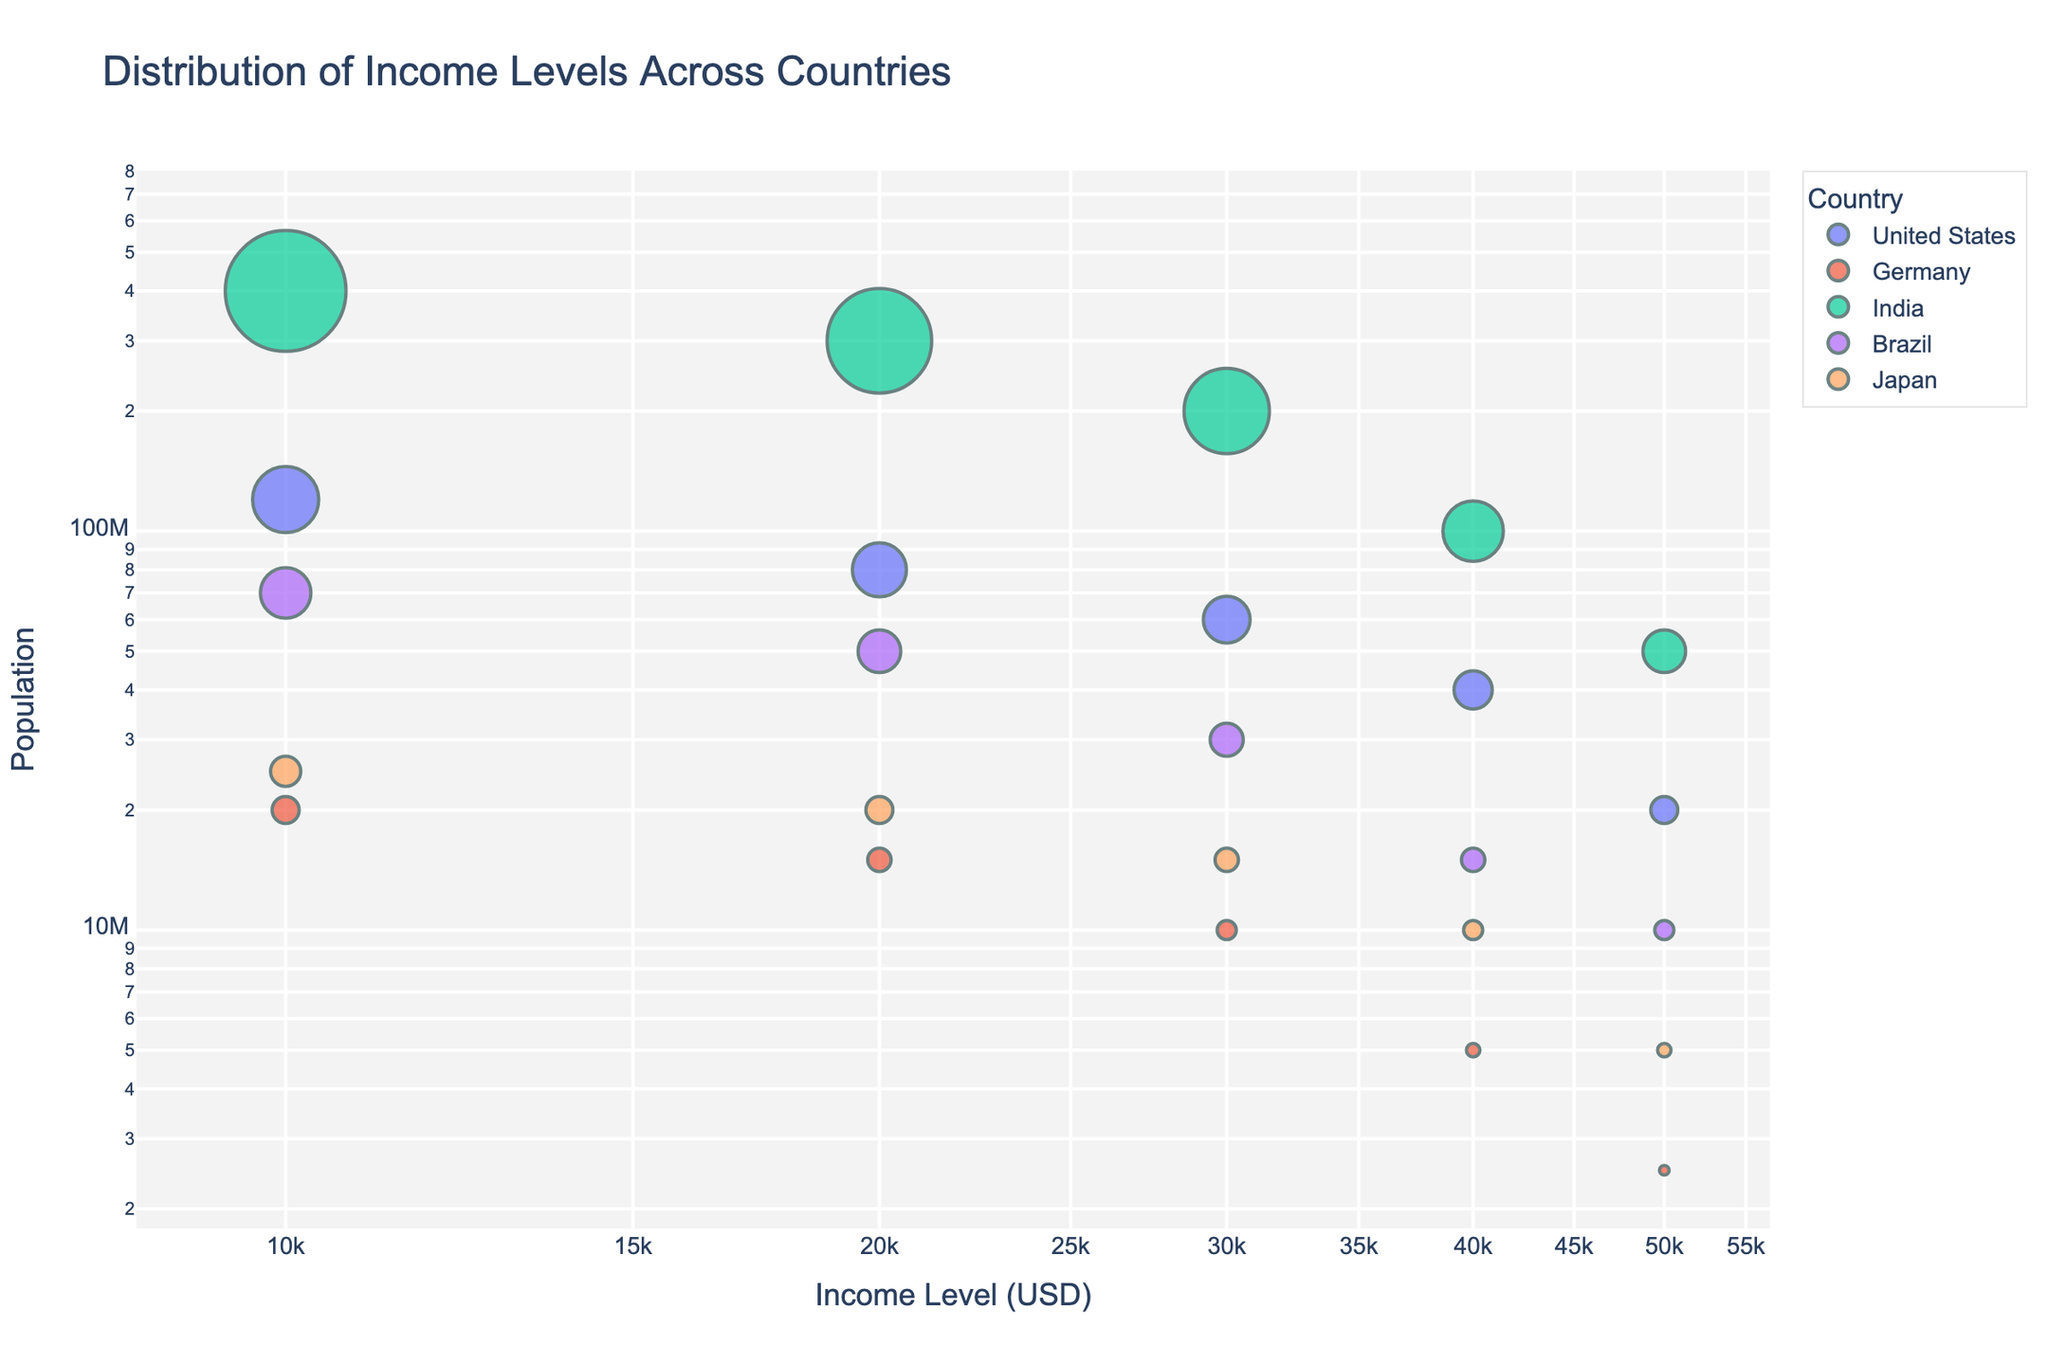What is the title of the plot? The title is usually displayed prominently at the top of the plot. It provides a summary of what the plot represents.
Answer: Distribution of Income Levels Across Countries Which country has the highest population at the $10,000 income level? To determine this, look at the data points representing each country's population at the $10,000 income level. The country with the highest y-axis value at this x-axis point has the highest population.
Answer: India What is the population of Japan at the $50,000 income level? Find the data point representing Japan for the $50,000 income level on the x-axis and check the corresponding y-axis value.
Answer: 5,000,000 How does the population of Brazil at $20,000 income level compare with that of Germany at the same income level? Locate the data points for Brazil and Germany at the $20,000 income level on the x-axis. Compare the corresponding y-axis values to see which one is higher.
Answer: Brazil has a higher population than Germany Which country has the smallest population at the $30,000 income level, excluding Brazil? Identify the data points for each country at the $30,000 income level on the x-axis. Compare the y-axis values and find the smallest one, excluding Brazil.
Answer: Germany What is the total population of all countries at $40,000 income level? Sum the population values for all countries at the $40,000 income level. For the United States it's 40,000,000, Germany it's 5,000,000, India it's 100,000,000, Brazil it's 15,000,000, and Japan it's 10,000,000. The total is 40,000,000 + 5,000,000 + 100,000,000 + 15,000,000 + 10,000,000.
Answer: 170,000,000 Among the given income levels, which one shows the most even distribution of populations across all countries? Check the data points for each income level and look at the spread of y-axis values for different countries. The income level where the y-axis values are more similar indicates a more even distribution.
Answer: $50,000 For the United States, how does the population at $30,000 income level compare to that at $40,000? Compare the y-axis values for the United States at the $30,000 and $40,000 income levels. 60,000,000 for $30,000 and 40,000,000 for $40,000.
Answer: The population is higher at $30,000 Which country shows the largest decrease in population from $10,000 to $50,000 income level? Calculate the difference in population for each country from $10,000 to $50,000 income levels. India has the largest values; from 400,000,000 to 50,000,000, the difference is 350,000,000.
Answer: India 